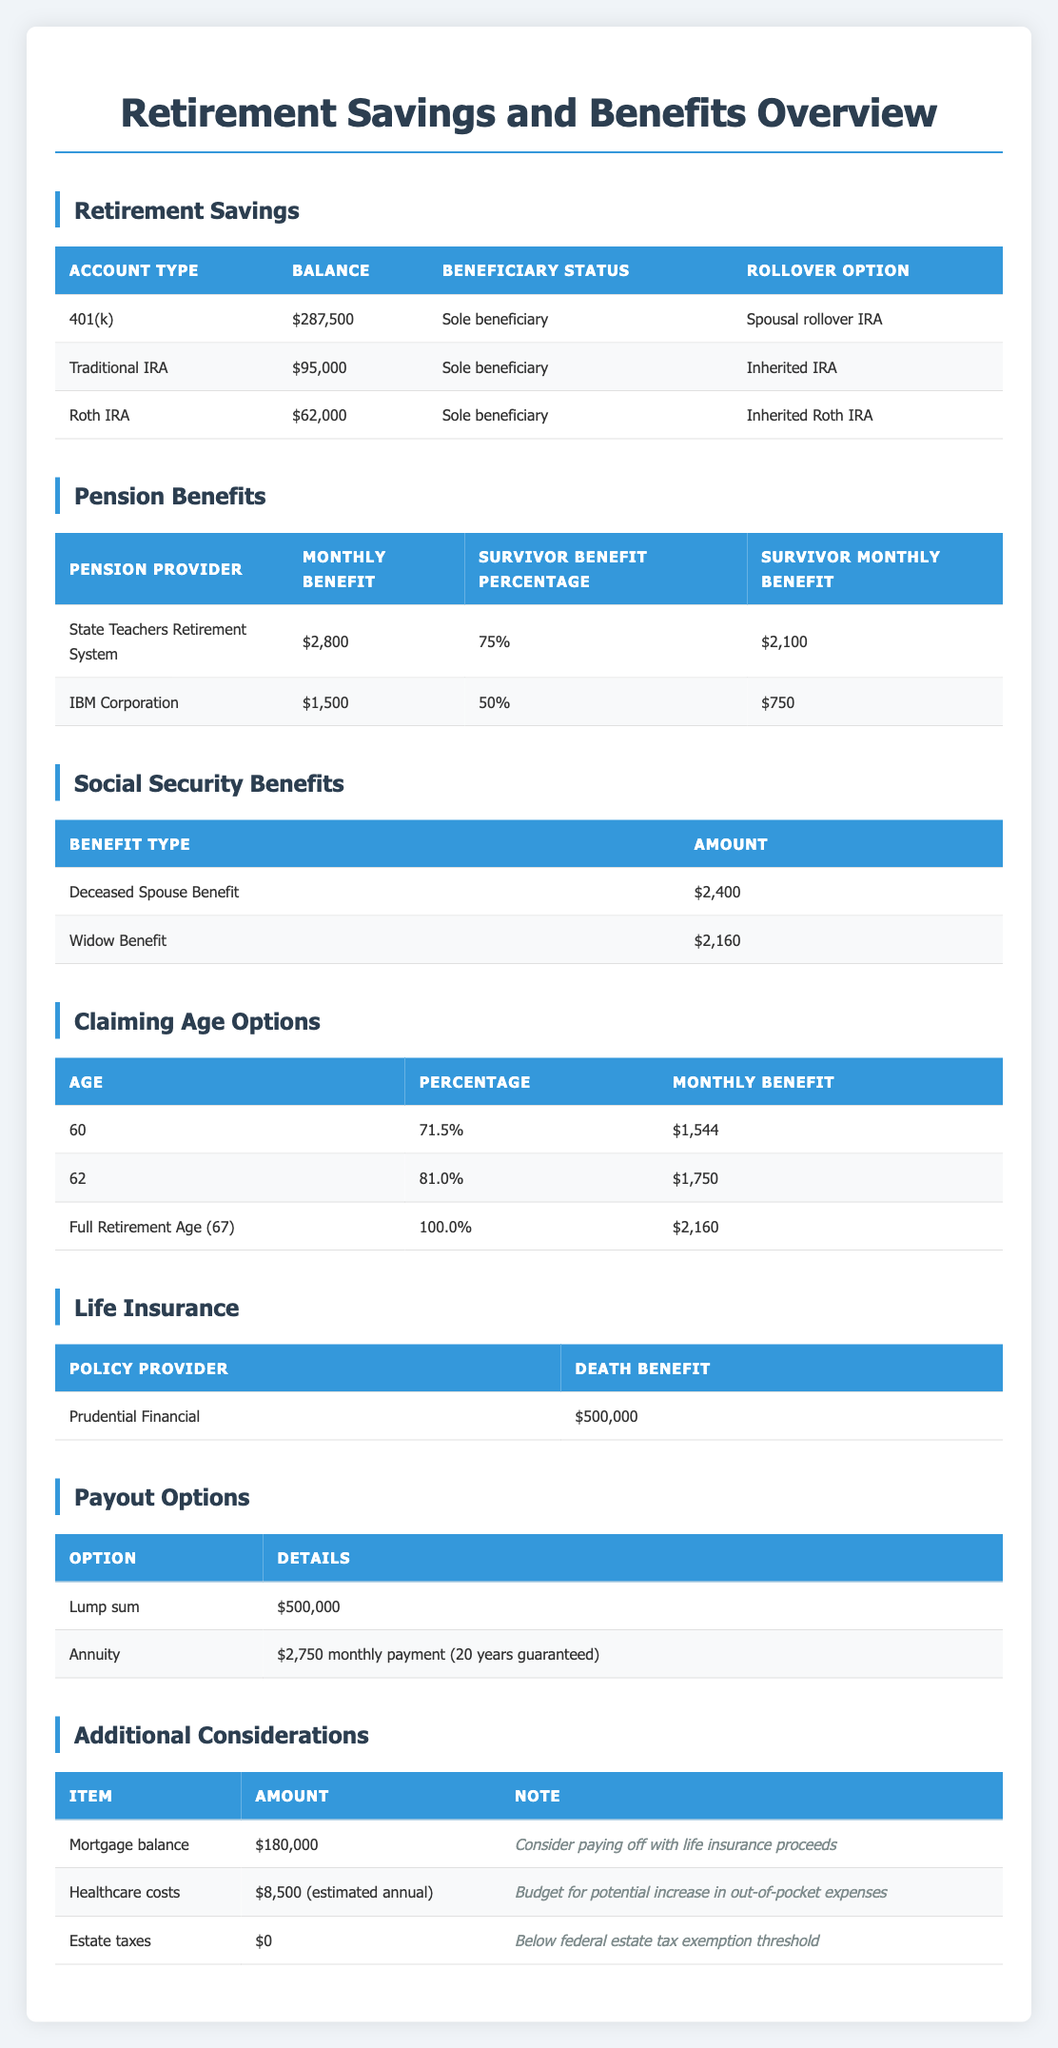What is the balance of the 401(k) account? The table lists the account types under the retirement savings section, and for the 401(k) account, the balance is shown as $287,500.
Answer: $287,500 What percentage of pension benefits can I expect to receive from the State Teachers Retirement System? According to the pension benefits table, the survivor benefit percentage from the State Teachers Retirement System is 75%.
Answer: 75% If I choose to claim the widow benefit now, how much would I receive monthly? In the social security benefits table, the widow benefit amount is listed as $2,160.
Answer: $2,160 What is the total balance of all retirement savings accounts? The balances listed are 401(k) $287,500, Traditional IRA $95,000, and Roth IRA $62,000. Adding these amounts gives us a total balance of $287,500 + $95,000 + $62,000 = $444,500.
Answer: $444,500 Is the estimated estate tax amount above the federal estate tax exemption threshold? The table shows the estimated estate tax amount as $0, and it notes that this is below the federal estate tax exemption threshold. Therefore, the answer is no.
Answer: No If I take the lump sum from the life insurance, what amount would be available? The life insurance section indicates that the lump sum payout option is $500,000.
Answer: $500,000 Which pension provider offers a higher survivor monthly benefit, and by how much? The State Teachers Retirement System provides a survivor monthly benefit of $2,100, while IBM Corporation provides $750. The difference is $2,100 - $750 = $1,350, indicating that the State Teachers Retirement System offers a higher benefit by $1,350.
Answer: State Teachers Retirement System; $1,350 How would claiming at age 62 affect my monthly benefit compared to claiming at full retirement age? The monthly benefit at age 62 is $1,750 and at full retirement age is $2,160. The difference is $2,160 - $1,750 = $410, meaning I would receive $410 less if I claim at age 62 instead of full retirement age.
Answer: $410 less What are the guaranteed period and monthly payment if I choose the annuity option from life insurance? The annuity option offers a monthly payment of $2,750 with a guaranteed period of 20 years according to the table.
Answer: $2,750; 20 years 